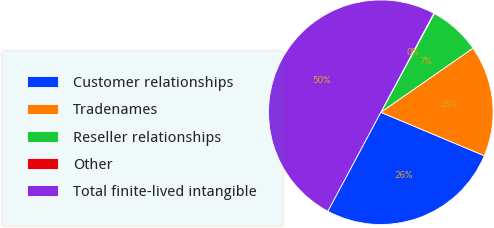Convert chart to OTSL. <chart><loc_0><loc_0><loc_500><loc_500><pie_chart><fcel>Customer relationships<fcel>Tradenames<fcel>Reseller relationships<fcel>Other<fcel>Total finite-lived intangible<nl><fcel>26.49%<fcel>16.0%<fcel>7.41%<fcel>0.09%<fcel>50.0%<nl></chart> 